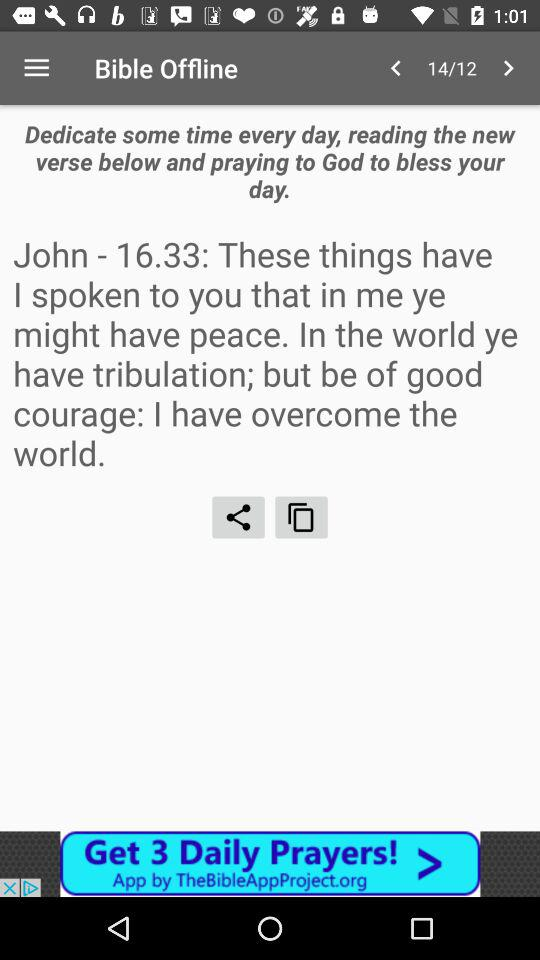What is the application name? The application name is "Bible Offline". 